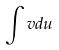Convert formula to latex. <formula><loc_0><loc_0><loc_500><loc_500>\int v d u</formula> 